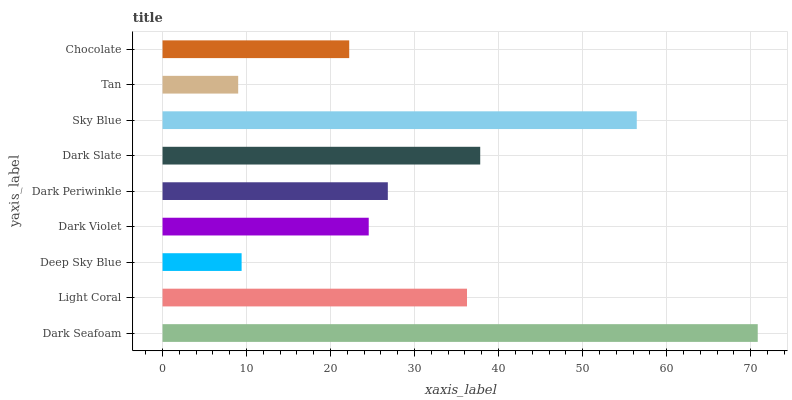Is Tan the minimum?
Answer yes or no. Yes. Is Dark Seafoam the maximum?
Answer yes or no. Yes. Is Light Coral the minimum?
Answer yes or no. No. Is Light Coral the maximum?
Answer yes or no. No. Is Dark Seafoam greater than Light Coral?
Answer yes or no. Yes. Is Light Coral less than Dark Seafoam?
Answer yes or no. Yes. Is Light Coral greater than Dark Seafoam?
Answer yes or no. No. Is Dark Seafoam less than Light Coral?
Answer yes or no. No. Is Dark Periwinkle the high median?
Answer yes or no. Yes. Is Dark Periwinkle the low median?
Answer yes or no. Yes. Is Tan the high median?
Answer yes or no. No. Is Light Coral the low median?
Answer yes or no. No. 